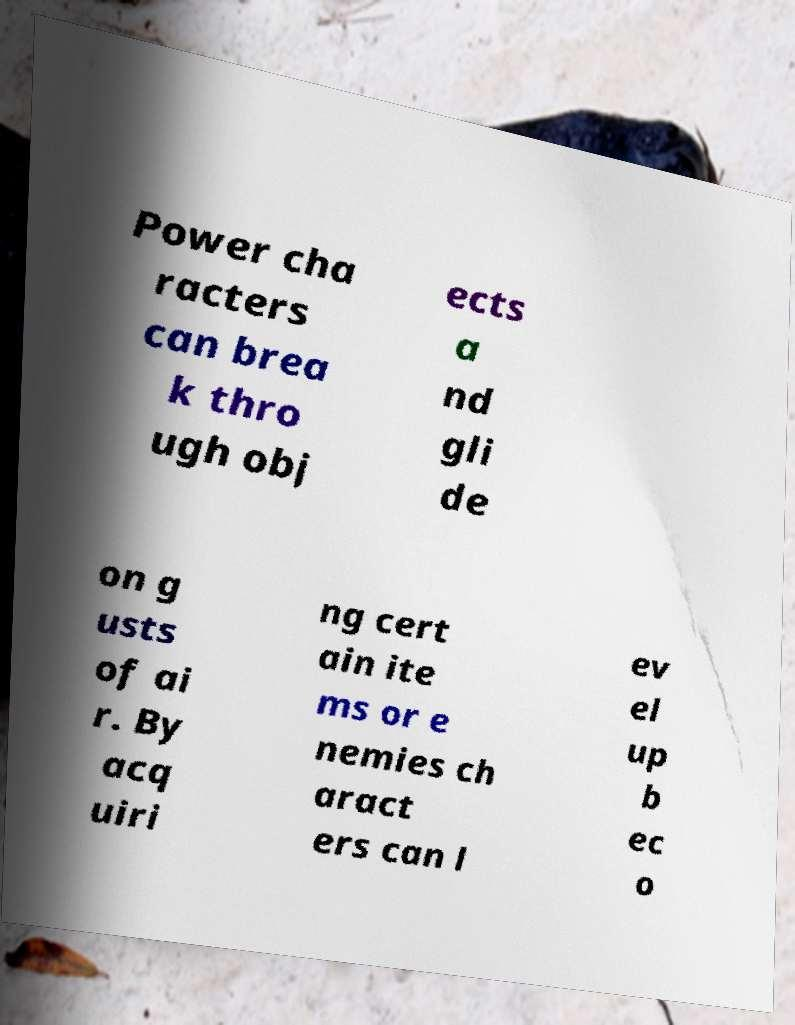What messages or text are displayed in this image? I need them in a readable, typed format. Power cha racters can brea k thro ugh obj ects a nd gli de on g usts of ai r. By acq uiri ng cert ain ite ms or e nemies ch aract ers can l ev el up b ec o 